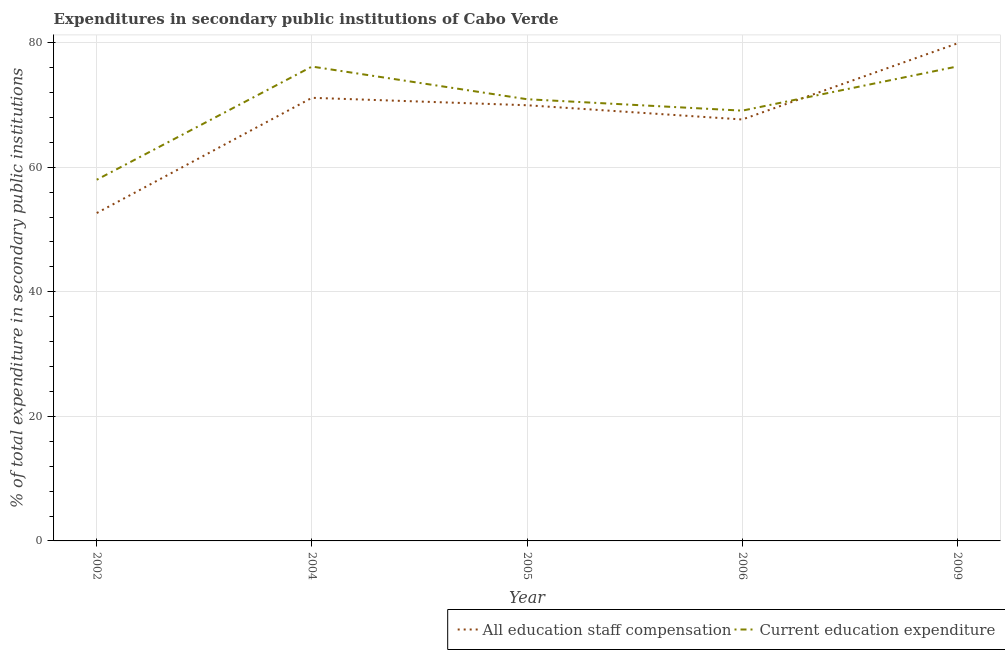How many different coloured lines are there?
Offer a very short reply. 2. Is the number of lines equal to the number of legend labels?
Offer a terse response. Yes. What is the expenditure in staff compensation in 2009?
Give a very brief answer. 79.89. Across all years, what is the maximum expenditure in staff compensation?
Your answer should be very brief. 79.89. Across all years, what is the minimum expenditure in education?
Make the answer very short. 58. In which year was the expenditure in education maximum?
Make the answer very short. 2009. What is the total expenditure in education in the graph?
Make the answer very short. 350.37. What is the difference between the expenditure in staff compensation in 2005 and that in 2006?
Your answer should be very brief. 2.29. What is the difference between the expenditure in staff compensation in 2002 and the expenditure in education in 2009?
Offer a terse response. -23.54. What is the average expenditure in education per year?
Your response must be concise. 70.07. In the year 2005, what is the difference between the expenditure in staff compensation and expenditure in education?
Your response must be concise. -0.97. What is the ratio of the expenditure in staff compensation in 2002 to that in 2004?
Offer a terse response. 0.74. Is the expenditure in education in 2006 less than that in 2009?
Give a very brief answer. Yes. What is the difference between the highest and the second highest expenditure in staff compensation?
Your response must be concise. 8.74. What is the difference between the highest and the lowest expenditure in education?
Your answer should be very brief. 18.19. Does the expenditure in staff compensation monotonically increase over the years?
Keep it short and to the point. No. Is the expenditure in education strictly greater than the expenditure in staff compensation over the years?
Give a very brief answer. No. How many lines are there?
Your response must be concise. 2. How many years are there in the graph?
Make the answer very short. 5. Does the graph contain any zero values?
Offer a very short reply. No. Does the graph contain grids?
Make the answer very short. Yes. Where does the legend appear in the graph?
Give a very brief answer. Bottom right. How many legend labels are there?
Give a very brief answer. 2. How are the legend labels stacked?
Offer a terse response. Horizontal. What is the title of the graph?
Provide a short and direct response. Expenditures in secondary public institutions of Cabo Verde. What is the label or title of the Y-axis?
Keep it short and to the point. % of total expenditure in secondary public institutions. What is the % of total expenditure in secondary public institutions of All education staff compensation in 2002?
Your answer should be compact. 52.65. What is the % of total expenditure in secondary public institutions of Current education expenditure in 2002?
Your answer should be compact. 58. What is the % of total expenditure in secondary public institutions of All education staff compensation in 2004?
Keep it short and to the point. 71.15. What is the % of total expenditure in secondary public institutions of Current education expenditure in 2004?
Your answer should be compact. 76.17. What is the % of total expenditure in secondary public institutions in All education staff compensation in 2005?
Provide a short and direct response. 69.96. What is the % of total expenditure in secondary public institutions in Current education expenditure in 2005?
Your answer should be very brief. 70.92. What is the % of total expenditure in secondary public institutions of All education staff compensation in 2006?
Your response must be concise. 67.67. What is the % of total expenditure in secondary public institutions in Current education expenditure in 2006?
Provide a short and direct response. 69.09. What is the % of total expenditure in secondary public institutions of All education staff compensation in 2009?
Your response must be concise. 79.89. What is the % of total expenditure in secondary public institutions of Current education expenditure in 2009?
Provide a succinct answer. 76.19. Across all years, what is the maximum % of total expenditure in secondary public institutions of All education staff compensation?
Your response must be concise. 79.89. Across all years, what is the maximum % of total expenditure in secondary public institutions in Current education expenditure?
Offer a terse response. 76.19. Across all years, what is the minimum % of total expenditure in secondary public institutions in All education staff compensation?
Keep it short and to the point. 52.65. Across all years, what is the minimum % of total expenditure in secondary public institutions of Current education expenditure?
Provide a short and direct response. 58. What is the total % of total expenditure in secondary public institutions in All education staff compensation in the graph?
Your answer should be very brief. 341.32. What is the total % of total expenditure in secondary public institutions in Current education expenditure in the graph?
Offer a terse response. 350.37. What is the difference between the % of total expenditure in secondary public institutions in All education staff compensation in 2002 and that in 2004?
Your answer should be very brief. -18.5. What is the difference between the % of total expenditure in secondary public institutions in Current education expenditure in 2002 and that in 2004?
Offer a terse response. -18.17. What is the difference between the % of total expenditure in secondary public institutions in All education staff compensation in 2002 and that in 2005?
Your response must be concise. -17.31. What is the difference between the % of total expenditure in secondary public institutions in Current education expenditure in 2002 and that in 2005?
Your answer should be very brief. -12.93. What is the difference between the % of total expenditure in secondary public institutions in All education staff compensation in 2002 and that in 2006?
Your response must be concise. -15.02. What is the difference between the % of total expenditure in secondary public institutions of Current education expenditure in 2002 and that in 2006?
Give a very brief answer. -11.1. What is the difference between the % of total expenditure in secondary public institutions of All education staff compensation in 2002 and that in 2009?
Keep it short and to the point. -27.24. What is the difference between the % of total expenditure in secondary public institutions of Current education expenditure in 2002 and that in 2009?
Offer a terse response. -18.19. What is the difference between the % of total expenditure in secondary public institutions of All education staff compensation in 2004 and that in 2005?
Offer a terse response. 1.19. What is the difference between the % of total expenditure in secondary public institutions in Current education expenditure in 2004 and that in 2005?
Give a very brief answer. 5.24. What is the difference between the % of total expenditure in secondary public institutions in All education staff compensation in 2004 and that in 2006?
Make the answer very short. 3.48. What is the difference between the % of total expenditure in secondary public institutions of Current education expenditure in 2004 and that in 2006?
Ensure brevity in your answer.  7.08. What is the difference between the % of total expenditure in secondary public institutions of All education staff compensation in 2004 and that in 2009?
Keep it short and to the point. -8.74. What is the difference between the % of total expenditure in secondary public institutions of Current education expenditure in 2004 and that in 2009?
Your response must be concise. -0.02. What is the difference between the % of total expenditure in secondary public institutions in All education staff compensation in 2005 and that in 2006?
Offer a terse response. 2.29. What is the difference between the % of total expenditure in secondary public institutions of Current education expenditure in 2005 and that in 2006?
Keep it short and to the point. 1.83. What is the difference between the % of total expenditure in secondary public institutions in All education staff compensation in 2005 and that in 2009?
Your response must be concise. -9.94. What is the difference between the % of total expenditure in secondary public institutions of Current education expenditure in 2005 and that in 2009?
Provide a short and direct response. -5.27. What is the difference between the % of total expenditure in secondary public institutions of All education staff compensation in 2006 and that in 2009?
Give a very brief answer. -12.22. What is the difference between the % of total expenditure in secondary public institutions of Current education expenditure in 2006 and that in 2009?
Make the answer very short. -7.1. What is the difference between the % of total expenditure in secondary public institutions of All education staff compensation in 2002 and the % of total expenditure in secondary public institutions of Current education expenditure in 2004?
Give a very brief answer. -23.52. What is the difference between the % of total expenditure in secondary public institutions in All education staff compensation in 2002 and the % of total expenditure in secondary public institutions in Current education expenditure in 2005?
Make the answer very short. -18.27. What is the difference between the % of total expenditure in secondary public institutions of All education staff compensation in 2002 and the % of total expenditure in secondary public institutions of Current education expenditure in 2006?
Offer a very short reply. -16.44. What is the difference between the % of total expenditure in secondary public institutions of All education staff compensation in 2002 and the % of total expenditure in secondary public institutions of Current education expenditure in 2009?
Your answer should be very brief. -23.54. What is the difference between the % of total expenditure in secondary public institutions in All education staff compensation in 2004 and the % of total expenditure in secondary public institutions in Current education expenditure in 2005?
Give a very brief answer. 0.23. What is the difference between the % of total expenditure in secondary public institutions in All education staff compensation in 2004 and the % of total expenditure in secondary public institutions in Current education expenditure in 2006?
Make the answer very short. 2.06. What is the difference between the % of total expenditure in secondary public institutions in All education staff compensation in 2004 and the % of total expenditure in secondary public institutions in Current education expenditure in 2009?
Offer a terse response. -5.04. What is the difference between the % of total expenditure in secondary public institutions of All education staff compensation in 2005 and the % of total expenditure in secondary public institutions of Current education expenditure in 2006?
Provide a short and direct response. 0.87. What is the difference between the % of total expenditure in secondary public institutions in All education staff compensation in 2005 and the % of total expenditure in secondary public institutions in Current education expenditure in 2009?
Provide a short and direct response. -6.23. What is the difference between the % of total expenditure in secondary public institutions in All education staff compensation in 2006 and the % of total expenditure in secondary public institutions in Current education expenditure in 2009?
Offer a terse response. -8.52. What is the average % of total expenditure in secondary public institutions of All education staff compensation per year?
Offer a terse response. 68.26. What is the average % of total expenditure in secondary public institutions of Current education expenditure per year?
Your answer should be very brief. 70.07. In the year 2002, what is the difference between the % of total expenditure in secondary public institutions of All education staff compensation and % of total expenditure in secondary public institutions of Current education expenditure?
Make the answer very short. -5.35. In the year 2004, what is the difference between the % of total expenditure in secondary public institutions of All education staff compensation and % of total expenditure in secondary public institutions of Current education expenditure?
Offer a very short reply. -5.02. In the year 2005, what is the difference between the % of total expenditure in secondary public institutions in All education staff compensation and % of total expenditure in secondary public institutions in Current education expenditure?
Your answer should be compact. -0.97. In the year 2006, what is the difference between the % of total expenditure in secondary public institutions of All education staff compensation and % of total expenditure in secondary public institutions of Current education expenditure?
Provide a short and direct response. -1.42. In the year 2009, what is the difference between the % of total expenditure in secondary public institutions of All education staff compensation and % of total expenditure in secondary public institutions of Current education expenditure?
Make the answer very short. 3.7. What is the ratio of the % of total expenditure in secondary public institutions in All education staff compensation in 2002 to that in 2004?
Your answer should be compact. 0.74. What is the ratio of the % of total expenditure in secondary public institutions in Current education expenditure in 2002 to that in 2004?
Provide a short and direct response. 0.76. What is the ratio of the % of total expenditure in secondary public institutions of All education staff compensation in 2002 to that in 2005?
Provide a short and direct response. 0.75. What is the ratio of the % of total expenditure in secondary public institutions of Current education expenditure in 2002 to that in 2005?
Keep it short and to the point. 0.82. What is the ratio of the % of total expenditure in secondary public institutions of All education staff compensation in 2002 to that in 2006?
Keep it short and to the point. 0.78. What is the ratio of the % of total expenditure in secondary public institutions in Current education expenditure in 2002 to that in 2006?
Offer a terse response. 0.84. What is the ratio of the % of total expenditure in secondary public institutions of All education staff compensation in 2002 to that in 2009?
Your answer should be compact. 0.66. What is the ratio of the % of total expenditure in secondary public institutions of Current education expenditure in 2002 to that in 2009?
Your answer should be very brief. 0.76. What is the ratio of the % of total expenditure in secondary public institutions in All education staff compensation in 2004 to that in 2005?
Keep it short and to the point. 1.02. What is the ratio of the % of total expenditure in secondary public institutions of Current education expenditure in 2004 to that in 2005?
Make the answer very short. 1.07. What is the ratio of the % of total expenditure in secondary public institutions in All education staff compensation in 2004 to that in 2006?
Give a very brief answer. 1.05. What is the ratio of the % of total expenditure in secondary public institutions of Current education expenditure in 2004 to that in 2006?
Ensure brevity in your answer.  1.1. What is the ratio of the % of total expenditure in secondary public institutions in All education staff compensation in 2004 to that in 2009?
Ensure brevity in your answer.  0.89. What is the ratio of the % of total expenditure in secondary public institutions in All education staff compensation in 2005 to that in 2006?
Provide a succinct answer. 1.03. What is the ratio of the % of total expenditure in secondary public institutions in Current education expenditure in 2005 to that in 2006?
Provide a succinct answer. 1.03. What is the ratio of the % of total expenditure in secondary public institutions in All education staff compensation in 2005 to that in 2009?
Your answer should be compact. 0.88. What is the ratio of the % of total expenditure in secondary public institutions of Current education expenditure in 2005 to that in 2009?
Keep it short and to the point. 0.93. What is the ratio of the % of total expenditure in secondary public institutions in All education staff compensation in 2006 to that in 2009?
Give a very brief answer. 0.85. What is the ratio of the % of total expenditure in secondary public institutions of Current education expenditure in 2006 to that in 2009?
Make the answer very short. 0.91. What is the difference between the highest and the second highest % of total expenditure in secondary public institutions in All education staff compensation?
Provide a short and direct response. 8.74. What is the difference between the highest and the second highest % of total expenditure in secondary public institutions of Current education expenditure?
Ensure brevity in your answer.  0.02. What is the difference between the highest and the lowest % of total expenditure in secondary public institutions of All education staff compensation?
Your answer should be compact. 27.24. What is the difference between the highest and the lowest % of total expenditure in secondary public institutions of Current education expenditure?
Make the answer very short. 18.19. 